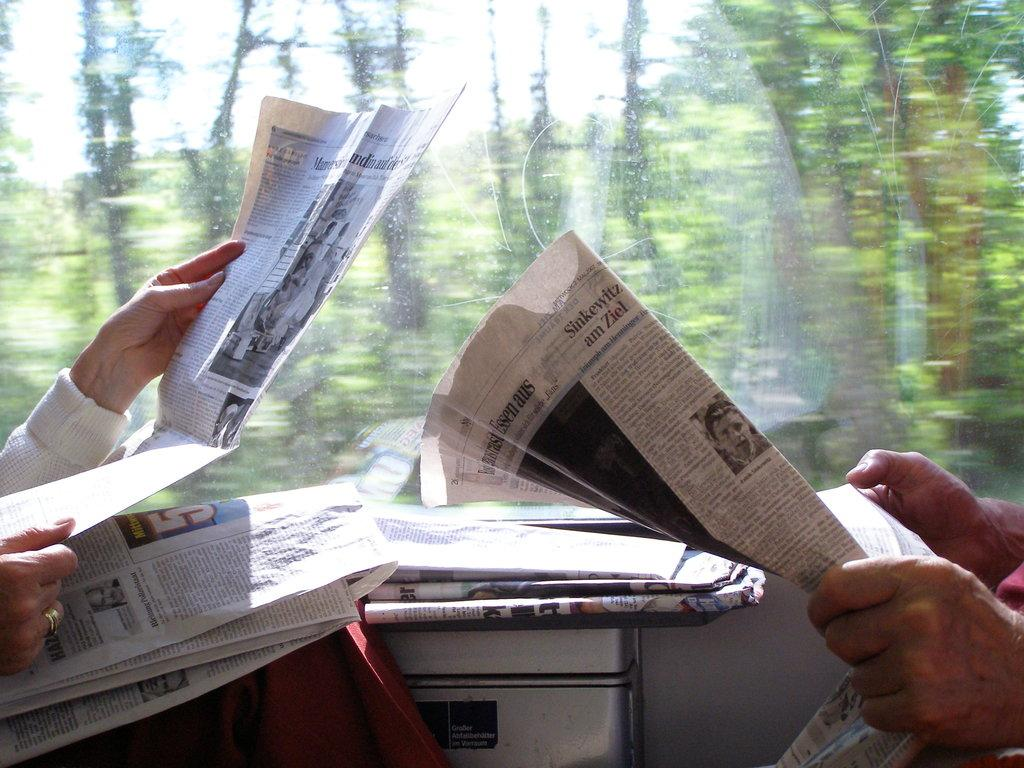How many people are present in the image? There are two people in the image. What are the two people holding in the image? The two people are holding newspapers. What can be seen through the window in the image? Trees are visible through the window in the image. What type of beam is being used to support the map in the image? There is no map or beam present in the image; it features two people holding newspapers and trees visible through a window. 